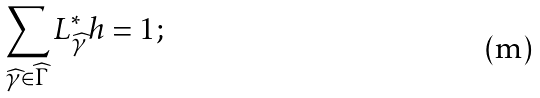<formula> <loc_0><loc_0><loc_500><loc_500>\sum _ { \widehat { \gamma } \in \widehat { \Gamma } } L _ { \widehat { \gamma } } ^ { * } h = 1 ;</formula> 